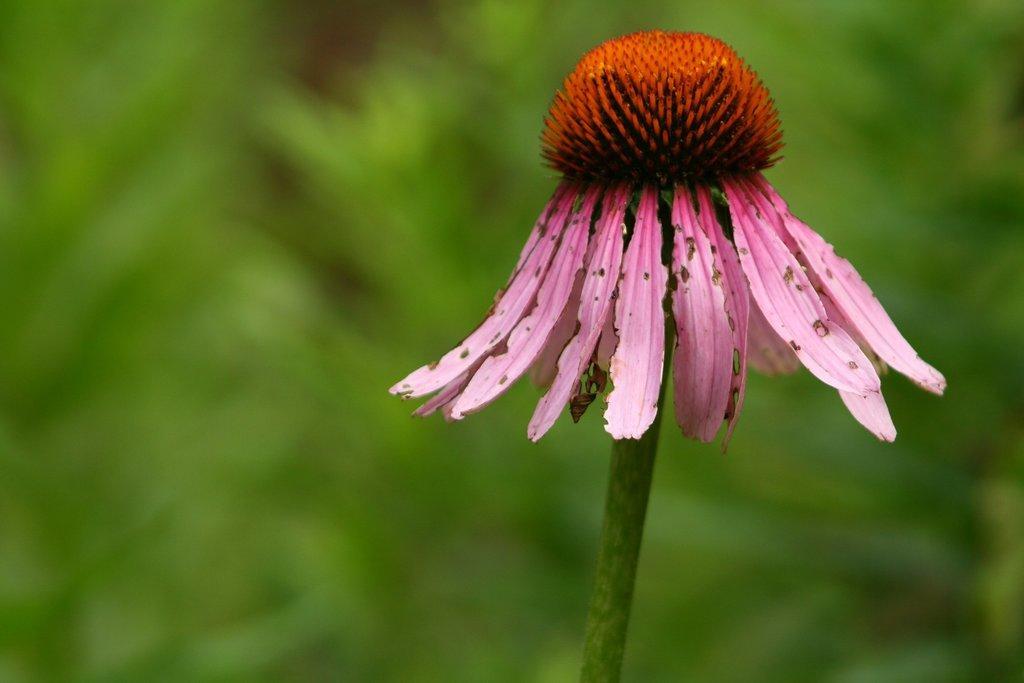Describe this image in one or two sentences. In this image we can see a flower with a stem. The background of the image is blur and green. 